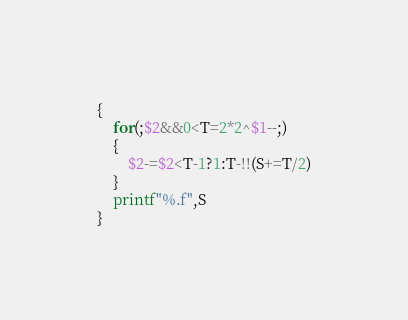<code> <loc_0><loc_0><loc_500><loc_500><_Perl_>{
	for(;$2&&0<T=2*2^$1--;)
	{
		$2-=$2<T-1?1:T-!!(S+=T/2)
	}
	printf"%.f",S
}</code> 